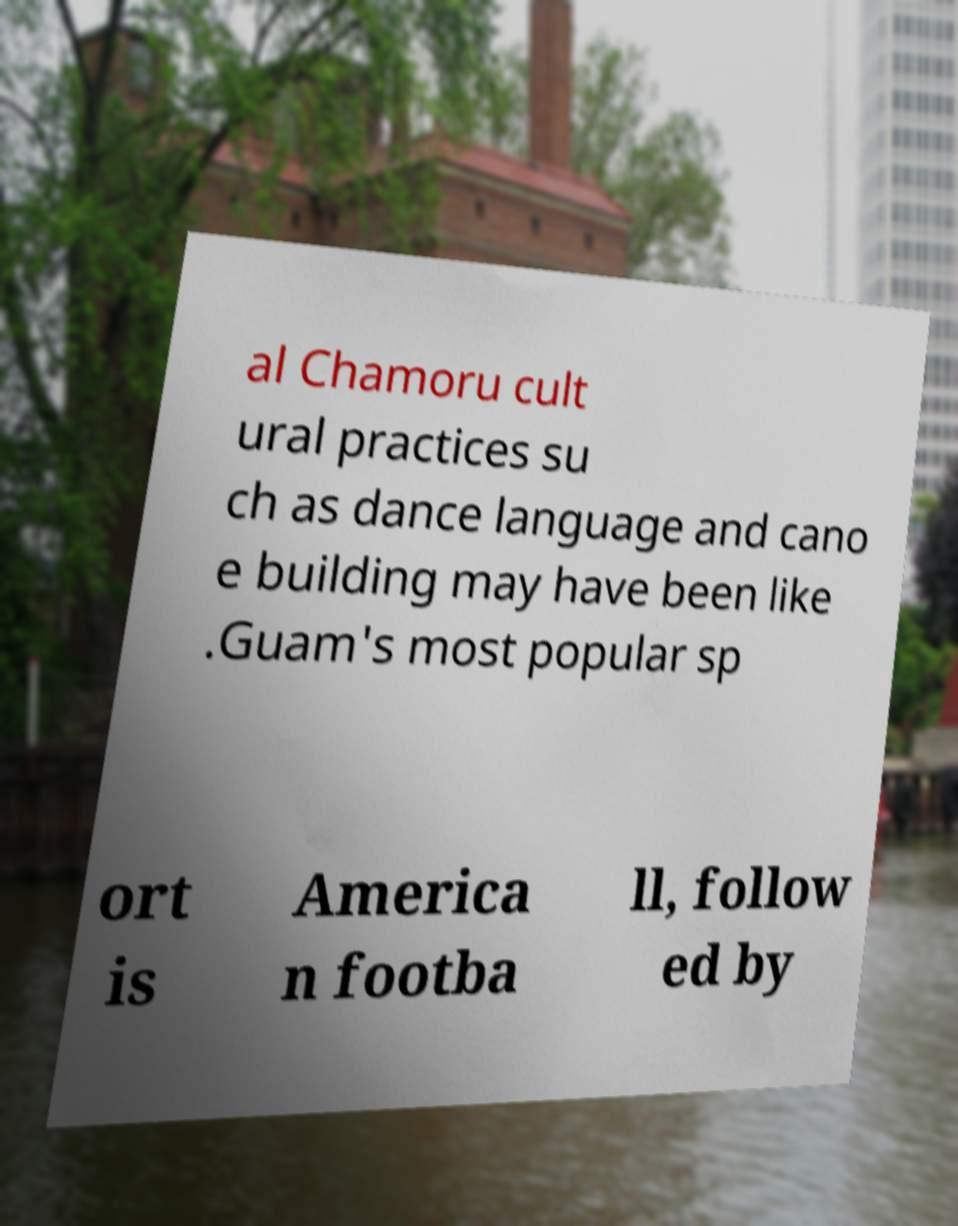Could you extract and type out the text from this image? al Chamoru cult ural practices su ch as dance language and cano e building may have been like .Guam's most popular sp ort is America n footba ll, follow ed by 